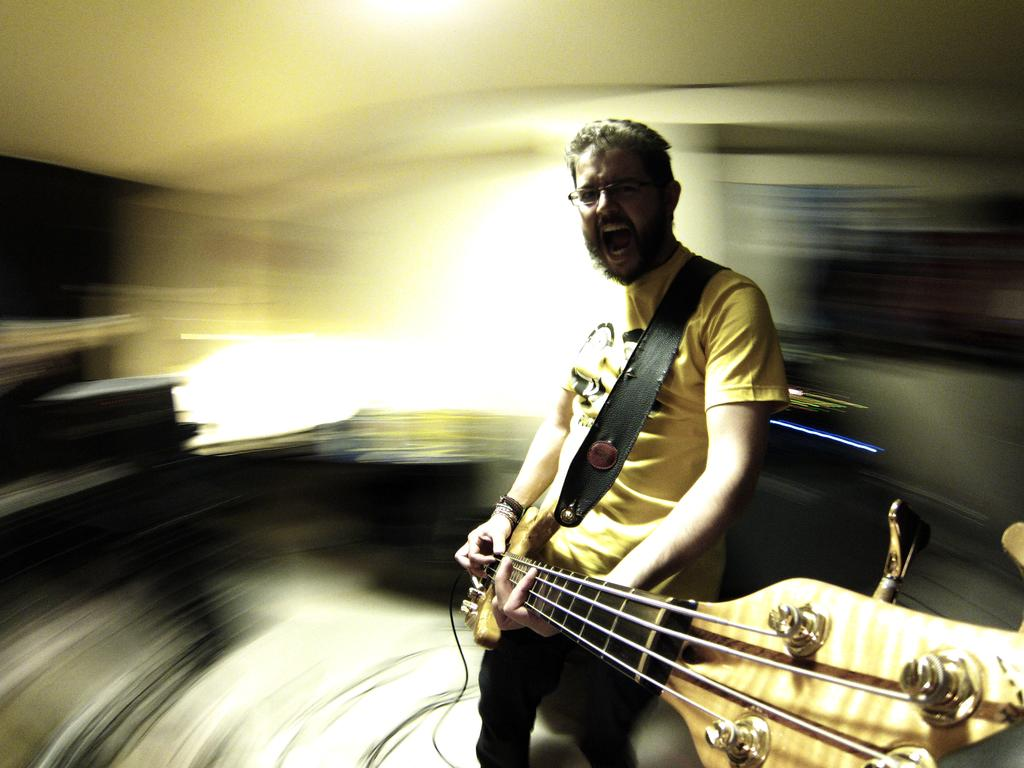What is the main subject of the image? The main subject of the image is a man. What is the man holding in the image? The man is holding a guitar. What type of flower is the man holding in the image? The man is not holding a flower in the image; he is holding a guitar. 